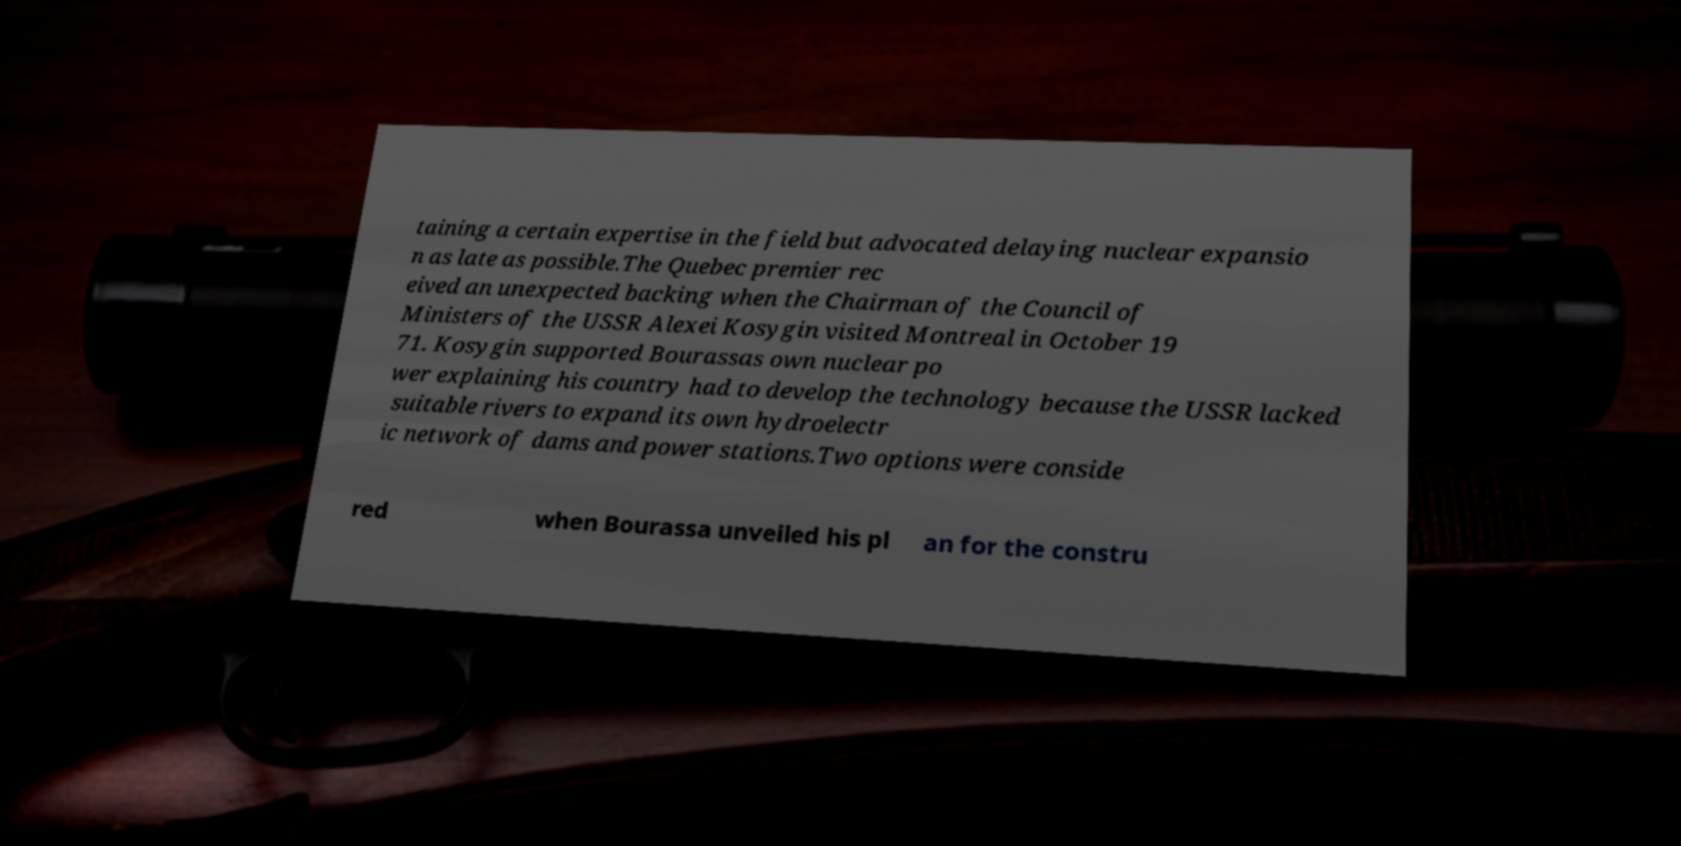What messages or text are displayed in this image? I need them in a readable, typed format. taining a certain expertise in the field but advocated delaying nuclear expansio n as late as possible.The Quebec premier rec eived an unexpected backing when the Chairman of the Council of Ministers of the USSR Alexei Kosygin visited Montreal in October 19 71. Kosygin supported Bourassas own nuclear po wer explaining his country had to develop the technology because the USSR lacked suitable rivers to expand its own hydroelectr ic network of dams and power stations.Two options were conside red when Bourassa unveiled his pl an for the constru 